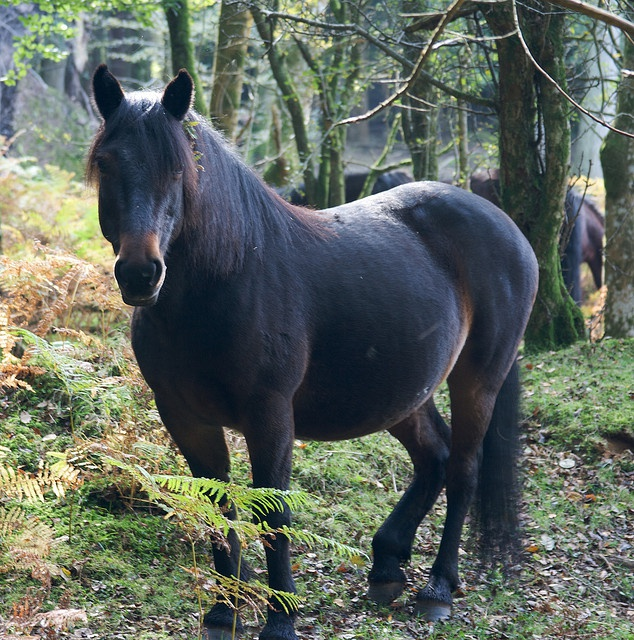Describe the objects in this image and their specific colors. I can see horse in green, black, gray, and darkblue tones and horse in green, gray, and black tones in this image. 